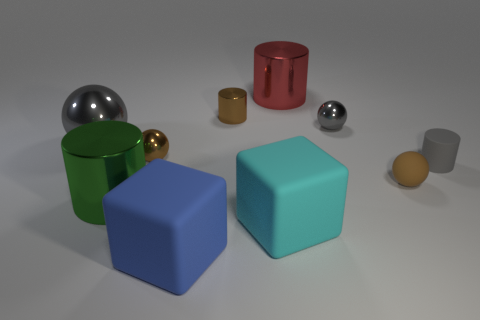What is the shape of the big gray thing that is the same material as the brown cylinder?
Ensure brevity in your answer.  Sphere. Does the large blue object have the same material as the large cyan cube right of the small brown metallic cylinder?
Your response must be concise. Yes. There is a object in front of the big cyan thing; does it have the same shape as the gray matte thing?
Your answer should be very brief. No. There is a cyan object that is the same shape as the blue object; what is its material?
Offer a very short reply. Rubber. Do the tiny gray matte object and the big thing to the left of the big green cylinder have the same shape?
Your answer should be compact. No. What color is the thing that is in front of the tiny brown shiny sphere and left of the big blue object?
Provide a succinct answer. Green. Are any small yellow matte cylinders visible?
Provide a short and direct response. No. Are there the same number of big metal objects right of the matte sphere and big green matte blocks?
Your response must be concise. Yes. How many other things are the same shape as the red metallic thing?
Offer a terse response. 3. What is the shape of the cyan rubber thing?
Offer a very short reply. Cube. 